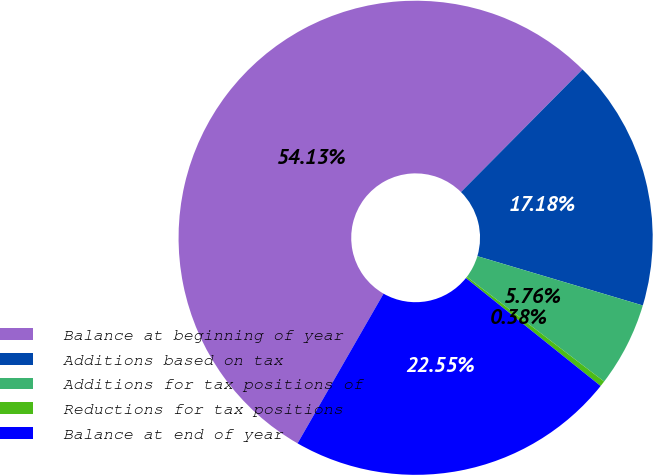Convert chart. <chart><loc_0><loc_0><loc_500><loc_500><pie_chart><fcel>Balance at beginning of year<fcel>Additions based on tax<fcel>Additions for tax positions of<fcel>Reductions for tax positions<fcel>Balance at end of year<nl><fcel>54.13%<fcel>17.18%<fcel>5.76%<fcel>0.38%<fcel>22.55%<nl></chart> 